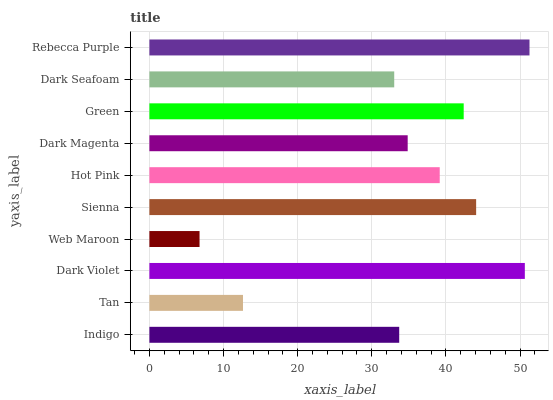Is Web Maroon the minimum?
Answer yes or no. Yes. Is Rebecca Purple the maximum?
Answer yes or no. Yes. Is Tan the minimum?
Answer yes or no. No. Is Tan the maximum?
Answer yes or no. No. Is Indigo greater than Tan?
Answer yes or no. Yes. Is Tan less than Indigo?
Answer yes or no. Yes. Is Tan greater than Indigo?
Answer yes or no. No. Is Indigo less than Tan?
Answer yes or no. No. Is Hot Pink the high median?
Answer yes or no. Yes. Is Dark Magenta the low median?
Answer yes or no. Yes. Is Sienna the high median?
Answer yes or no. No. Is Sienna the low median?
Answer yes or no. No. 